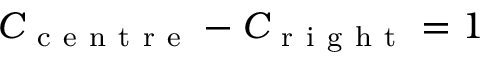<formula> <loc_0><loc_0><loc_500><loc_500>C _ { c e n t r e } - C _ { r i g h t } = 1</formula> 